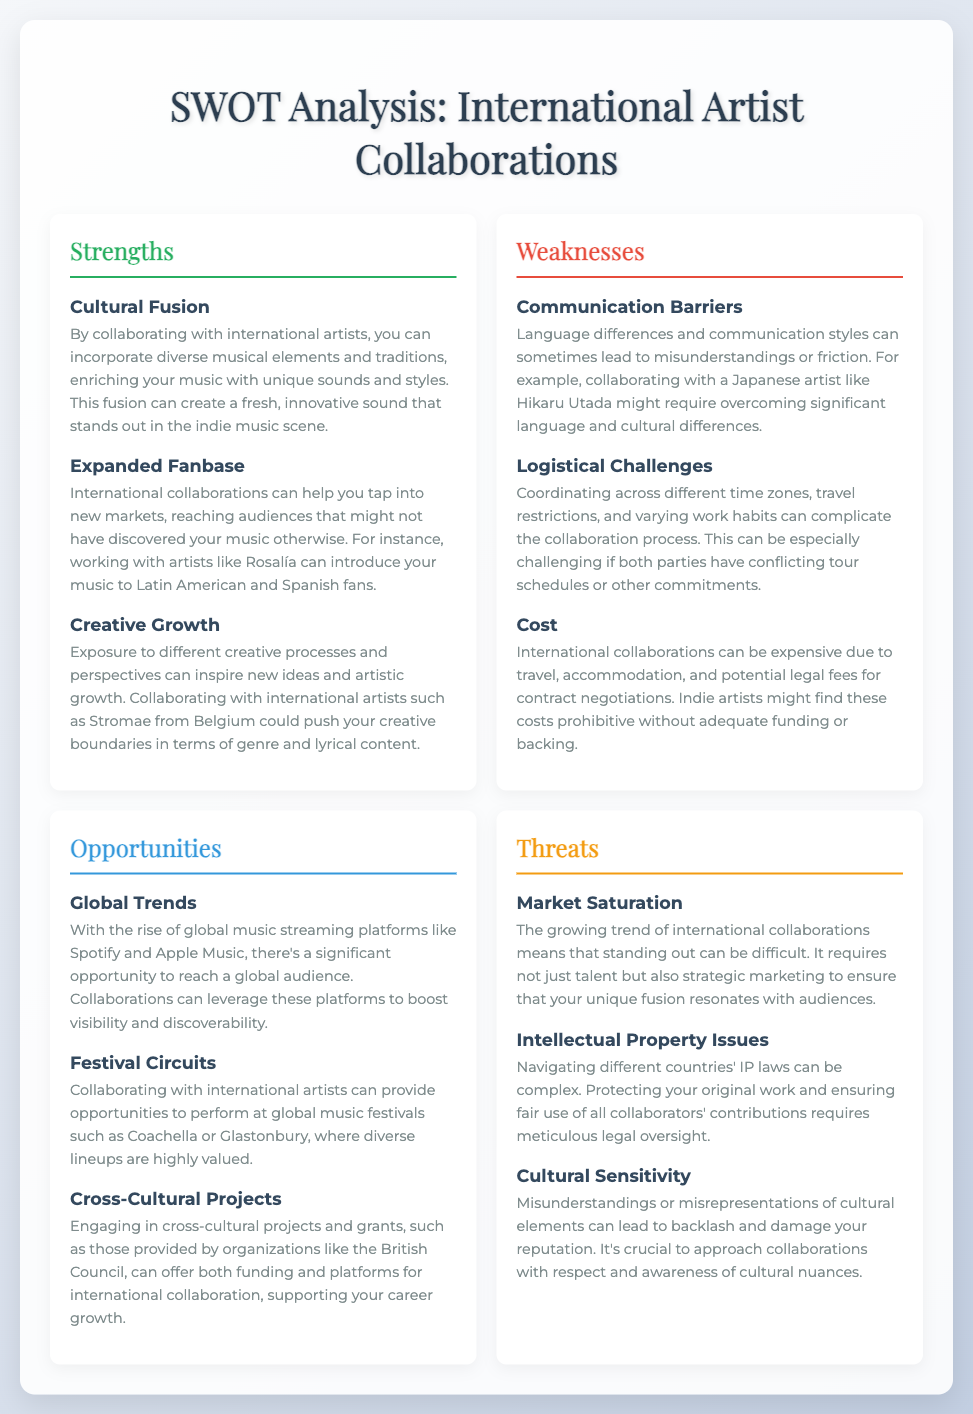What are the strengths of international artist collaborations? The strengths listed include Cultural Fusion, Expanded Fanbase, and Creative Growth.
Answer: Cultural Fusion, Expanded Fanbase, Creative Growth What is one weakness related to communication in international collaborations? The document states that language differences can lead to misunderstandings or friction.
Answer: Communication Barriers What is an opportunity presented by global music streaming platforms? The document indicates the rise of global music streaming platforms enables reaching a global audience.
Answer: Global audience What are two logistical challenges mentioned? The document mentions travel restrictions and conflicting tour schedules as logistical challenges.
Answer: Travel restrictions, conflicting tour schedules What is a threat associated with market dynamics in artist collaborations? The document highlights the challenge of standing out in a growing trend of international collaborations.
Answer: Market Saturation Which festival circuit is specifically mentioned as an opportunity for performances? The document lists global music festivals like Coachella and Glastonbury as potential opportunities.
Answer: Coachella, Glastonbury Name one cultural issue that poses a threat to international collaborations. The document states that misunderstandings or misrepresentations of cultural elements can damage reputation.
Answer: Cultural Sensitivity What is a specific legal concern highlighted in the threats? The document mentions that navigating different countries' intellectual property laws can be complex.
Answer: Intellectual Property Issues 